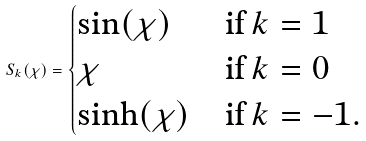Convert formula to latex. <formula><loc_0><loc_0><loc_500><loc_500>S _ { k } ( \chi ) = \begin{cases} \sin ( \chi ) & \text {if} \, k = 1 \\ \chi & \text {if} \, k = 0 \\ \sinh ( \chi ) & \text {if} \, k = - 1 . \end{cases}</formula> 